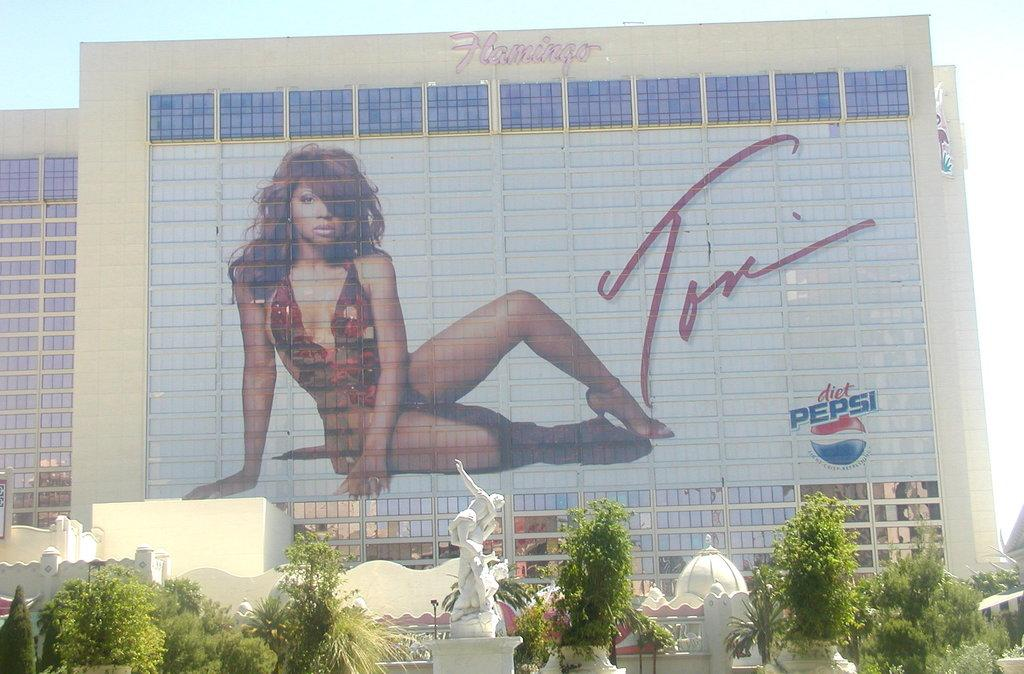What can be seen on the wall of the building in the image? There is a girl's picture on the wall of a building in the image. What is located in the foreground of the image? There is a statue and a group of trees in the foreground. What is visible in the background of the image? The sky is visible in the background. Is the girl in the picture sleeping or engaged in a battle in the image? The girl in the picture is not sleeping or engaged in a battle, as these elements are not present in the image. Can you see any ghosts in the image? There are no ghosts visible in the image. 